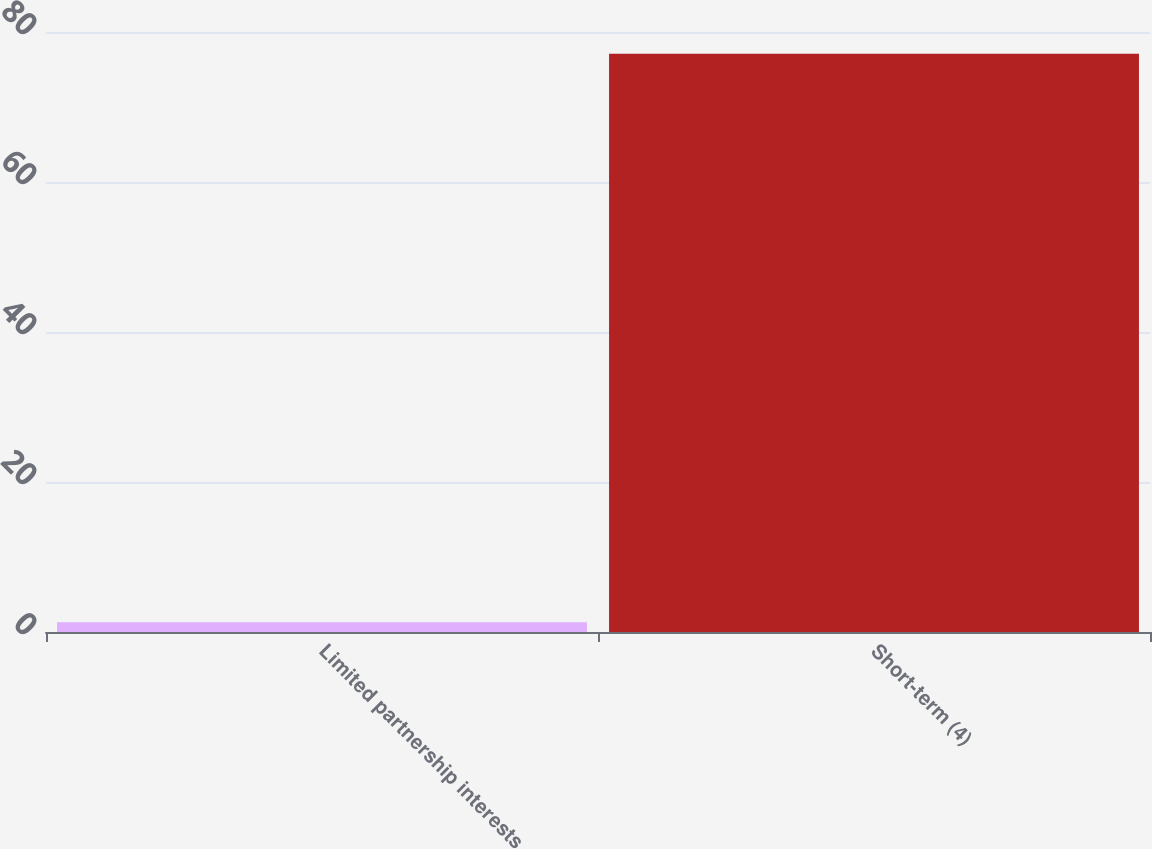Convert chart. <chart><loc_0><loc_0><loc_500><loc_500><bar_chart><fcel>Limited partnership interests<fcel>Short-term (4)<nl><fcel>1.3<fcel>77.1<nl></chart> 